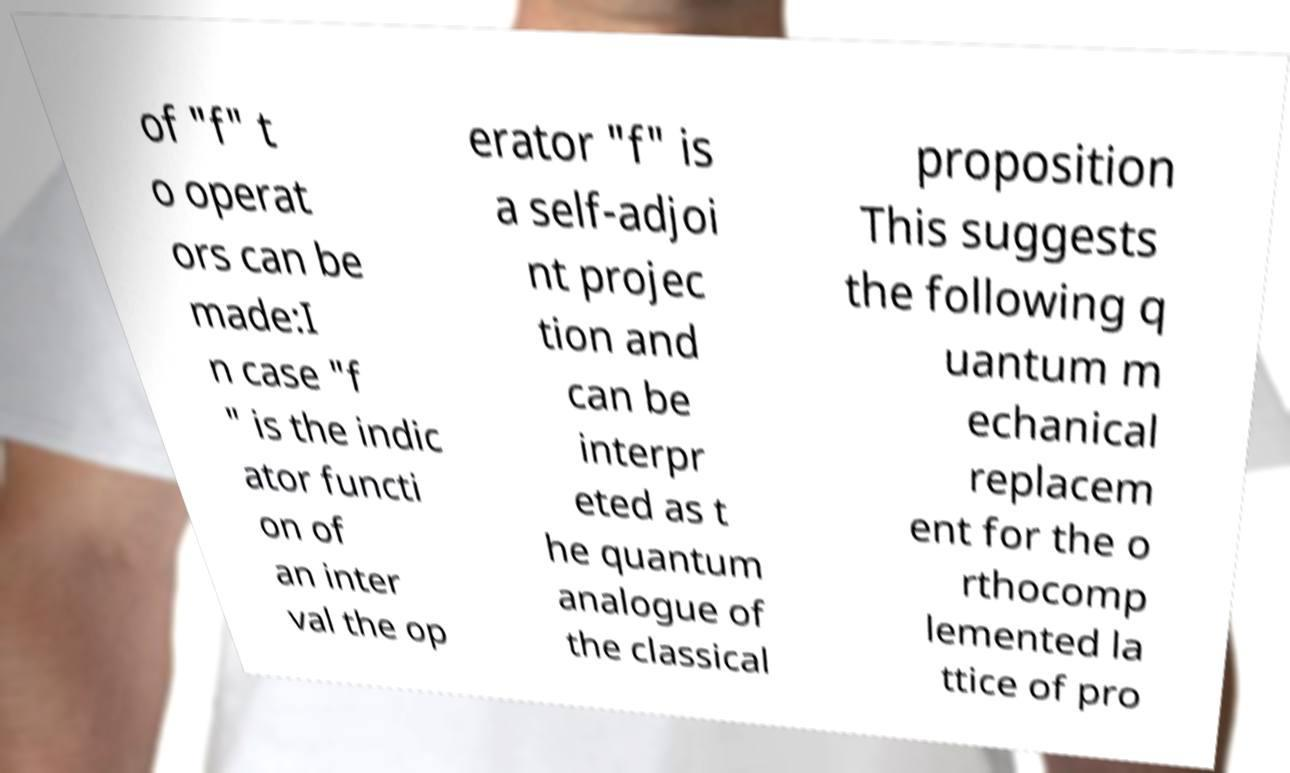Can you read and provide the text displayed in the image?This photo seems to have some interesting text. Can you extract and type it out for me? of "f" t o operat ors can be made:I n case "f " is the indic ator functi on of an inter val the op erator "f" is a self-adjoi nt projec tion and can be interpr eted as t he quantum analogue of the classical proposition This suggests the following q uantum m echanical replacem ent for the o rthocomp lemented la ttice of pro 